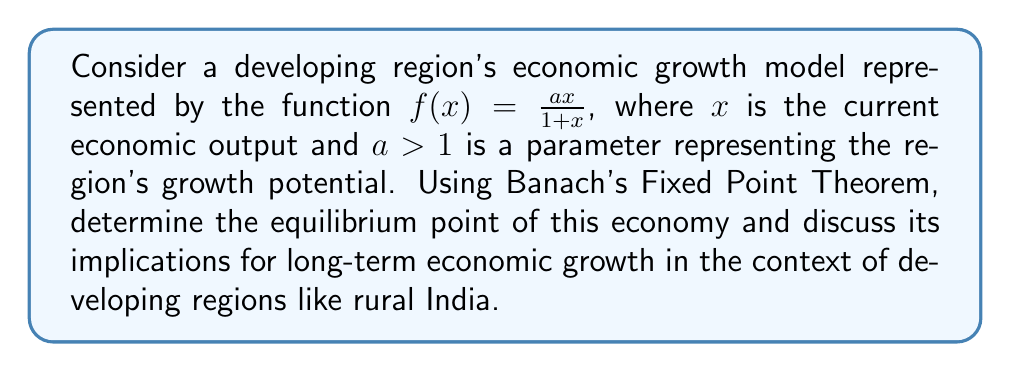Teach me how to tackle this problem. 1) First, we need to verify that Banach's Fixed Point Theorem applies:

   a) The function $f(x) = \frac{ax}{1+x}$ is continuous on $[0,\infty)$.
   
   b) We need to show that $f$ maps $[0,M]$ into itself for some $M > 0$:
      $f(0) = 0$ and $\lim_{x \to \infty} f(x) = a$
      So, we can choose $M = a$.

   c) We need to prove that $f$ is a contraction on $[0,a]$:
      $f'(x) = \frac{a}{(1+x)^2}$
      On $[0,a]$, $0 < f'(x) \leq a$, so $f$ is Lipschitz with constant $a$.
      Since $a > 1$, $f$ is not a contraction on $[0,a]$.

2) To make $f$ a contraction, we can consider $g(x) = \frac{f(x)}{a} = \frac{x}{1+x}$

   Now, $g'(x) = \frac{1}{(1+x)^2} < 1$ for all $x > 0$

3) Applying Banach's Fixed Point Theorem to $g$:
   The fixed point of $g$ satisfies $x = g(x) = \frac{x}{1+x}$
   Solving this equation: $x + x^2 = x$, $x^2 = 0$, so $x = 0$

4) The fixed point of $f$ is the same as $g$, so the equilibrium point is $x^* = 0$

5) Interpretation: In this model, the economy of the developing region will converge to zero output in the long run, regardless of its initial state. This suggests that without additional factors or interventions, the region may face economic stagnation.

6) For developing regions like rural India, this model implies that relying solely on the current economic structure may not lead to sustainable growth. Policymakers should consider:
   - Increasing the parameter $a$ through technological advancements or skill development
   - Modifying the model to include additional growth factors like education or infrastructure
   - Implementing targeted interventions to break out of the zero-growth equilibrium
Answer: Equilibrium point: $x^* = 0$ 